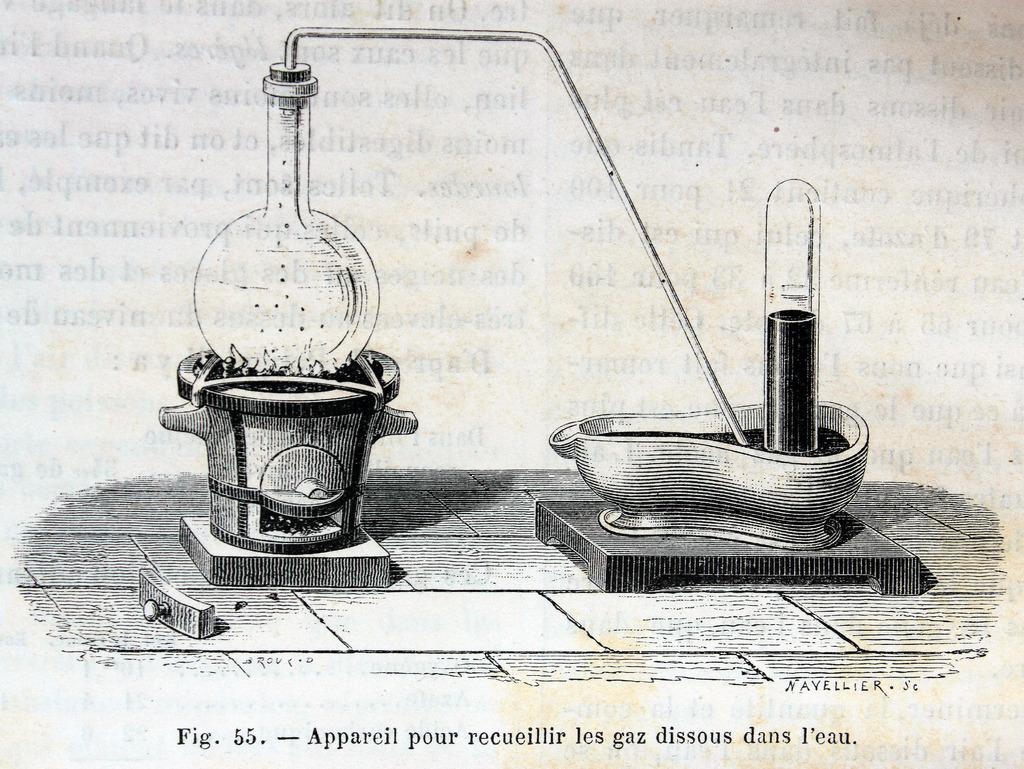<image>
Give a short and clear explanation of the subsequent image. a page that says 'fig.55.-appareil pour recueillir les gaz dissous dans l'eau.' at the bottom 